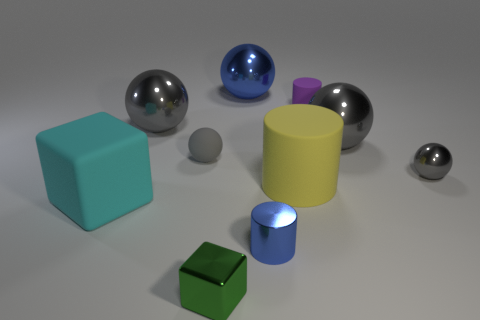Subtract all gray balls. How many were subtracted if there are1gray balls left? 3 Subtract all tiny metallic cylinders. How many cylinders are left? 2 Subtract all yellow blocks. How many gray balls are left? 4 Subtract 2 balls. How many balls are left? 3 Subtract all blue balls. How many balls are left? 4 Subtract all cylinders. How many objects are left? 7 Add 7 large blocks. How many large blocks exist? 8 Subtract 0 red balls. How many objects are left? 10 Subtract all yellow spheres. Subtract all red cylinders. How many spheres are left? 5 Subtract all purple matte blocks. Subtract all big gray shiny objects. How many objects are left? 8 